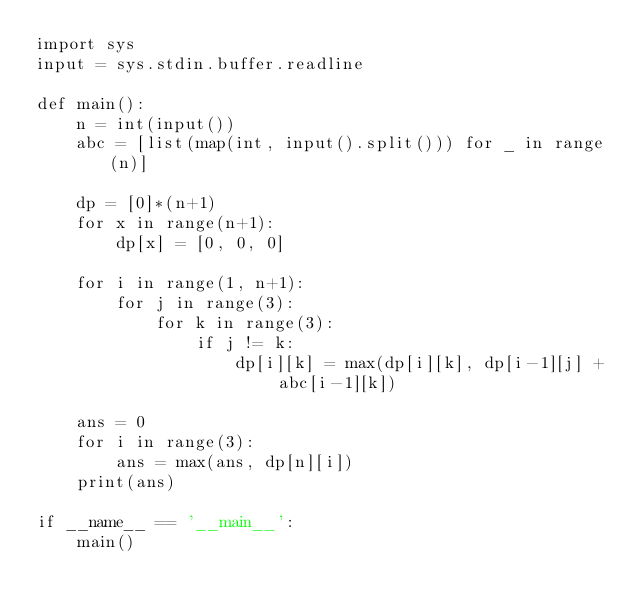<code> <loc_0><loc_0><loc_500><loc_500><_Python_>import sys
input = sys.stdin.buffer.readline

def main():
    n = int(input())
    abc = [list(map(int, input().split())) for _ in range(n)]

    dp = [0]*(n+1)
    for x in range(n+1):
        dp[x] = [0, 0, 0]

    for i in range(1, n+1):
        for j in range(3):
            for k in range(3):
                if j != k:
                    dp[i][k] = max(dp[i][k], dp[i-1][j] + abc[i-1][k])

    ans = 0
    for i in range(3):
        ans = max(ans, dp[n][i])
    print(ans)

if __name__ == '__main__':
    main()</code> 